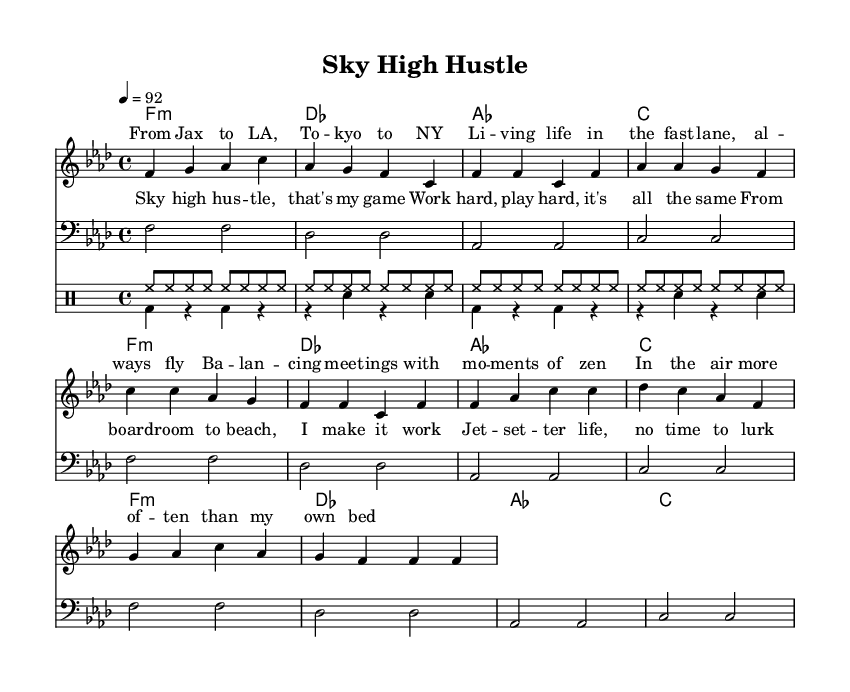What is the key signature of this music? The key signature is indicated at the beginning of the score, showing the presence of four flats, which corresponds to F minor.
Answer: F minor What is the time signature of the piece? The time signature is noted in the score right after the key signature, reading 4/4, meaning there are four beats in each measure.
Answer: 4/4 What is the tempo marking for this piece? The tempo is indicated with a metronome marking showing "4 = 92", indicating the speed at which the piece should be played.
Answer: 92 How many measures are in the verse section? By counting the measures labeled for the verse section (noted in the score), we find that there are 4 measures in total.
Answer: 4 What is the main theme of the lyrics presented in this rap? The lyrics express the lifestyle of a jet-setter balancing work and leisure, focusing on the contrast between business meetings and enjoyment.
Answer: Jet-setter life Which musical element is used to represent the rhythm in the drum section? The rhythm in the drum section is represented with the use of hihat and bass drum notation, defining the rhythmic pattern and tempo feel.
Answer: Hihat and bass drum What is the main dynamic expression indicated throughout the piece? Dynamics are not explicitly marked in the sheet music, but the consistent rhythmic figure indicates a moderate dynamic level appropriate for rap music.
Answer: Moderate 